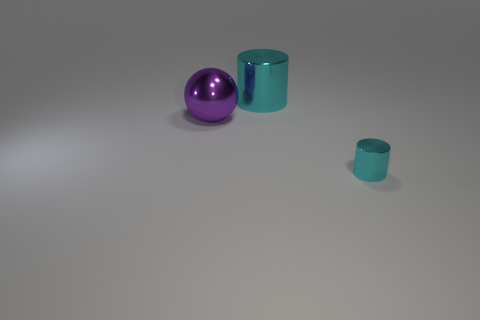Are there any small cyan metallic objects left of the big sphere behind the thing that is in front of the big purple metallic thing?
Keep it short and to the point. No. What number of objects are small purple cubes or big cylinders?
Your answer should be compact. 1. There is another cylinder that is made of the same material as the small cylinder; what is its color?
Provide a short and direct response. Cyan. Do the cyan thing in front of the ball and the big cyan object have the same shape?
Give a very brief answer. Yes. What number of objects are cyan cylinders in front of the purple ball or objects behind the tiny object?
Keep it short and to the point. 3. There is a large shiny object that is the same shape as the tiny thing; what is its color?
Offer a very short reply. Cyan. Is there any other thing that is the same shape as the purple object?
Provide a succinct answer. No. Does the tiny metallic thing have the same shape as the big thing behind the large purple shiny object?
Provide a short and direct response. Yes. There is another cyan metal thing that is the same shape as the big cyan metallic thing; what is its size?
Your answer should be very brief. Small. How many other objects are there of the same material as the purple thing?
Make the answer very short. 2. 